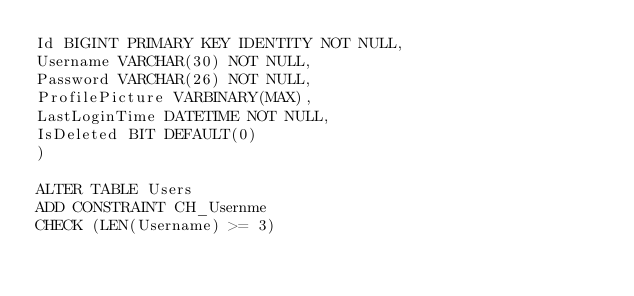Convert code to text. <code><loc_0><loc_0><loc_500><loc_500><_SQL_>Id BIGINT PRIMARY KEY IDENTITY NOT NULL,
Username VARCHAR(30) NOT NULL,
Password VARCHAR(26) NOT NULL,
ProfilePicture VARBINARY(MAX),
LastLoginTime DATETIME NOT NULL,
IsDeleted BIT DEFAULT(0)
)

ALTER TABLE Users
ADD CONSTRAINT CH_Usernme
CHECK (LEN(Username) >= 3)</code> 